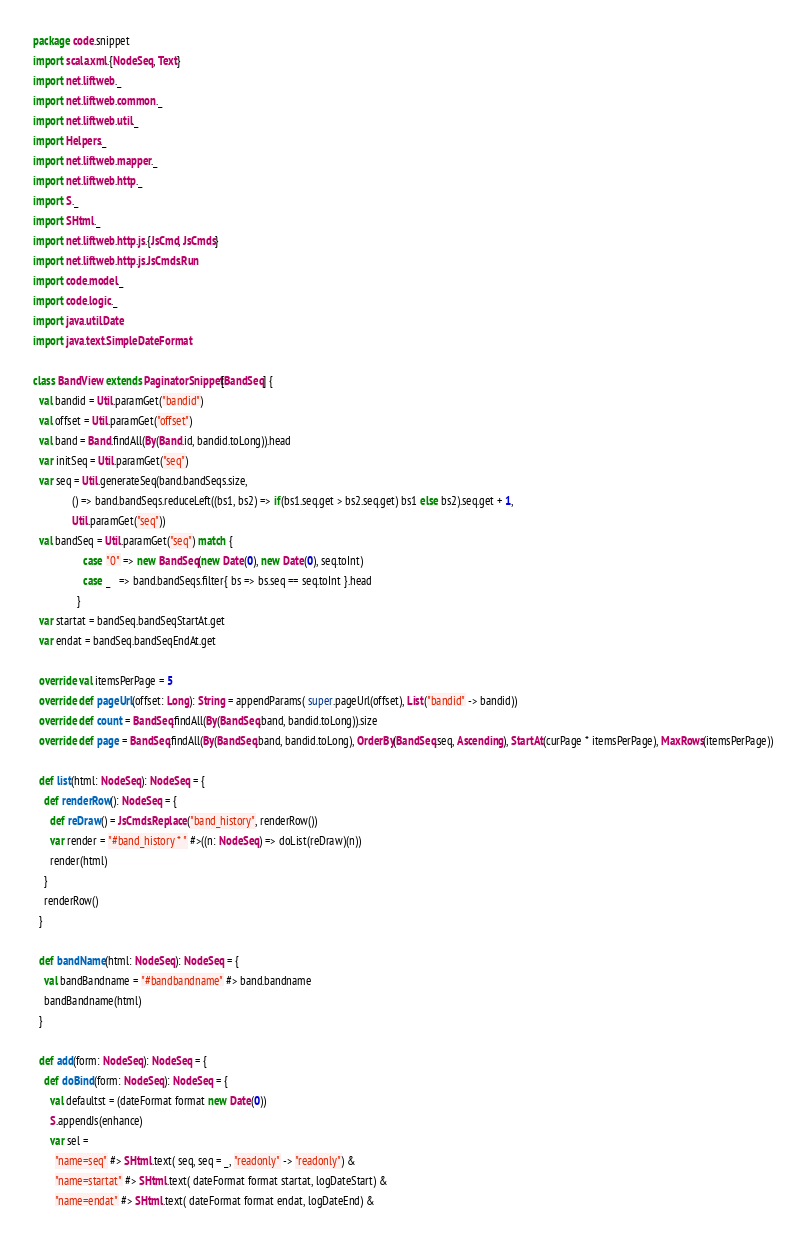Convert code to text. <code><loc_0><loc_0><loc_500><loc_500><_Scala_>package code.snippet
import scala.xml.{NodeSeq, Text}
import net.liftweb._
import net.liftweb.common._
import net.liftweb.util._
import Helpers._
import net.liftweb.mapper._
import net.liftweb.http._
import S._
import SHtml._
import net.liftweb.http.js.{JsCmd, JsCmds}
import net.liftweb.http.js.JsCmds.Run
import code.model._
import code.logic._
import java.util.Date
import java.text.SimpleDateFormat

class BandView extends PaginatorSnippet[BandSeq] {
  val bandid = Util.paramGet("bandid")
  val offset = Util.paramGet("offset")
  val band = Band.findAll(By(Band.id, bandid.toLong)).head
  var initSeq = Util.paramGet("seq")
  var seq = Util.generateSeq(band.bandSeqs.size,
              () => band.bandSeqs.reduceLeft((bs1, bs2) => if(bs1.seq.get > bs2.seq.get) bs1 else bs2).seq.get + 1,
              Util.paramGet("seq"))
  val bandSeq = Util.paramGet("seq") match {
                  case "0" => new BandSeq(new Date(0), new Date(0), seq.toInt)
                  case _   => band.bandSeqs.filter{ bs => bs.seq == seq.toInt }.head
                }
  var startat = bandSeq.bandSeqStartAt.get
  var endat = bandSeq.bandSeqEndAt.get

  override val itemsPerPage = 5
  override def pageUrl(offset: Long): String = appendParams( super.pageUrl(offset), List("bandid" -> bandid))
  override def count = BandSeq.findAll(By(BandSeq.band, bandid.toLong)).size
  override def page = BandSeq.findAll(By(BandSeq.band, bandid.toLong), OrderBy(BandSeq.seq, Ascending), StartAt(curPage * itemsPerPage), MaxRows(itemsPerPage))

  def list(html: NodeSeq): NodeSeq = {
    def renderRow(): NodeSeq = {
      def reDraw() = JsCmds.Replace("band_history", renderRow())
      var render = "#band_history * " #>((n: NodeSeq) => doList(reDraw)(n))
      render(html)
    }
    renderRow()
  }

  def bandName(html: NodeSeq): NodeSeq = {
    val bandBandname = "#bandbandname" #> band.bandname
    bandBandname(html)
  }
  
  def add(form: NodeSeq): NodeSeq = {
    def doBind(form: NodeSeq): NodeSeq = {
      val defaultst = (dateFormat format new Date(0))
      S.appendJs(enhance)
      var sel =
        "name=seq" #> SHtml.text( seq, seq = _, "readonly" -> "readonly") &
        "name=startat" #> SHtml.text( dateFormat format startat, logDateStart) &
        "name=endat" #> SHtml.text( dateFormat format endat, logDateEnd) &</code> 